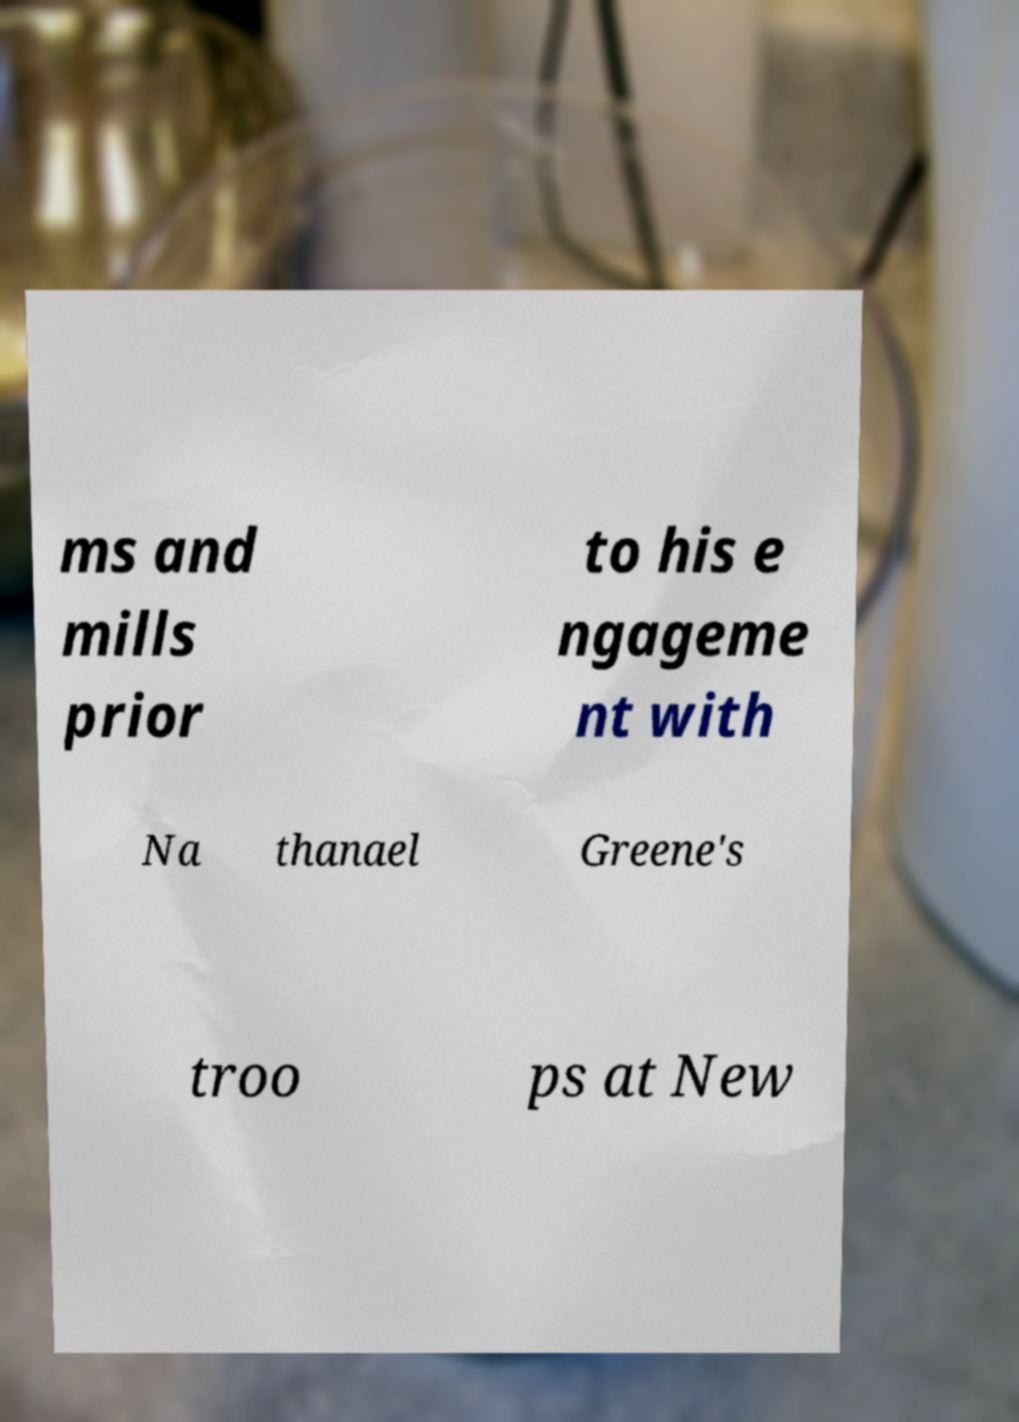Could you assist in decoding the text presented in this image and type it out clearly? ms and mills prior to his e ngageme nt with Na thanael Greene's troo ps at New 